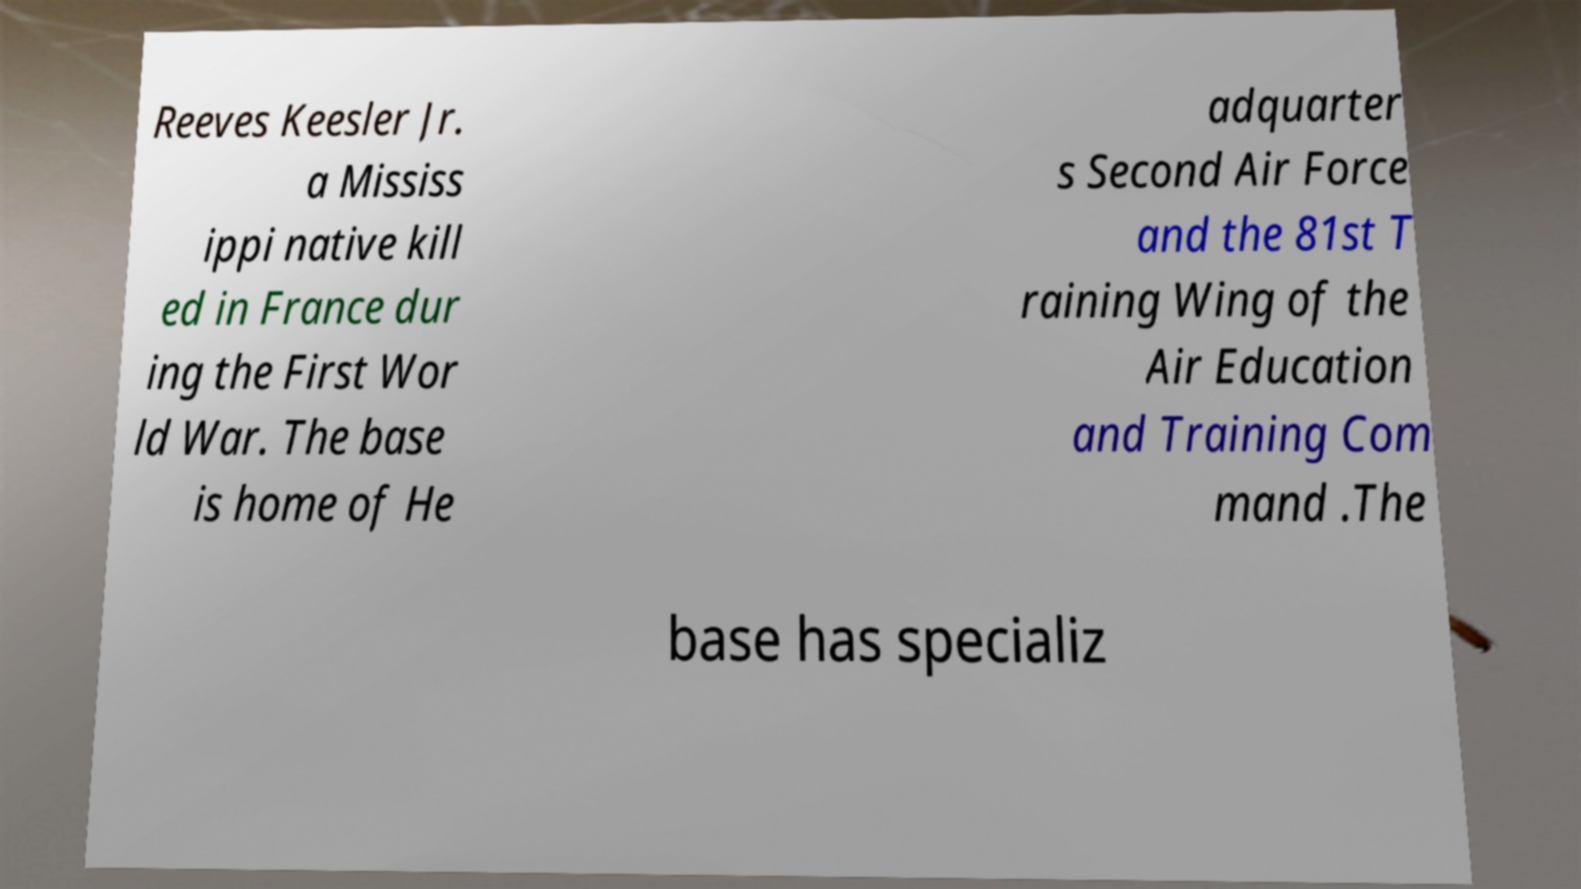Can you accurately transcribe the text from the provided image for me? Reeves Keesler Jr. a Mississ ippi native kill ed in France dur ing the First Wor ld War. The base is home of He adquarter s Second Air Force and the 81st T raining Wing of the Air Education and Training Com mand .The base has specializ 